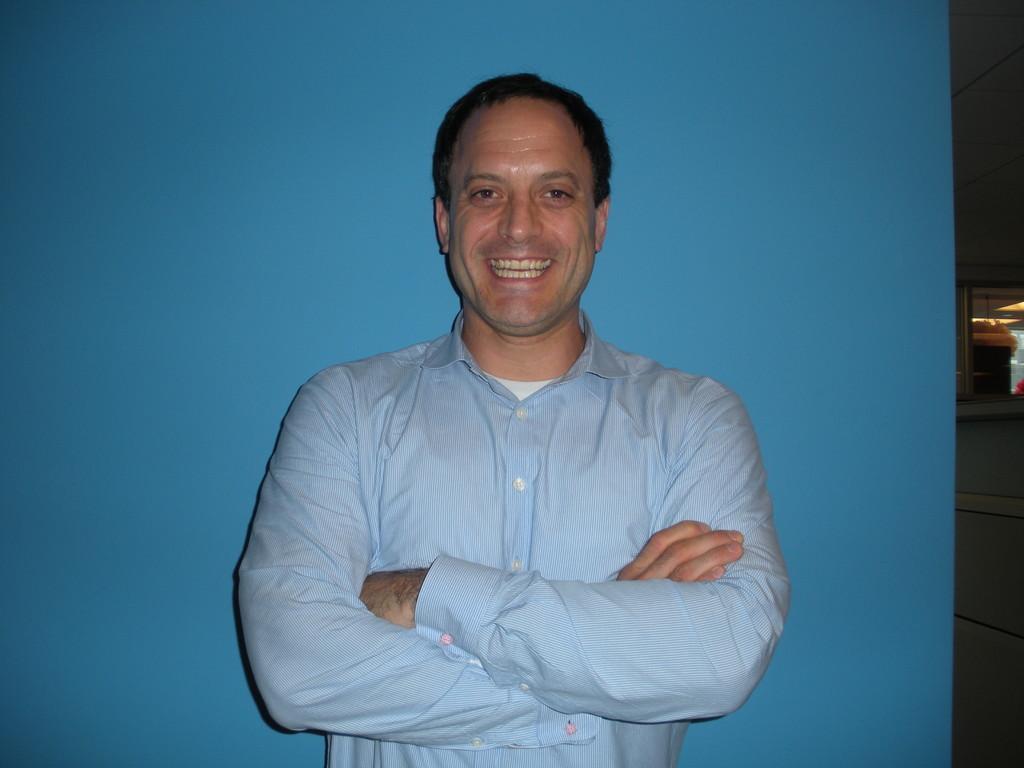Can you describe this image briefly? In the center of the image, we can see a person standing and smiling and in the background, there is a wall and we can see a window. 